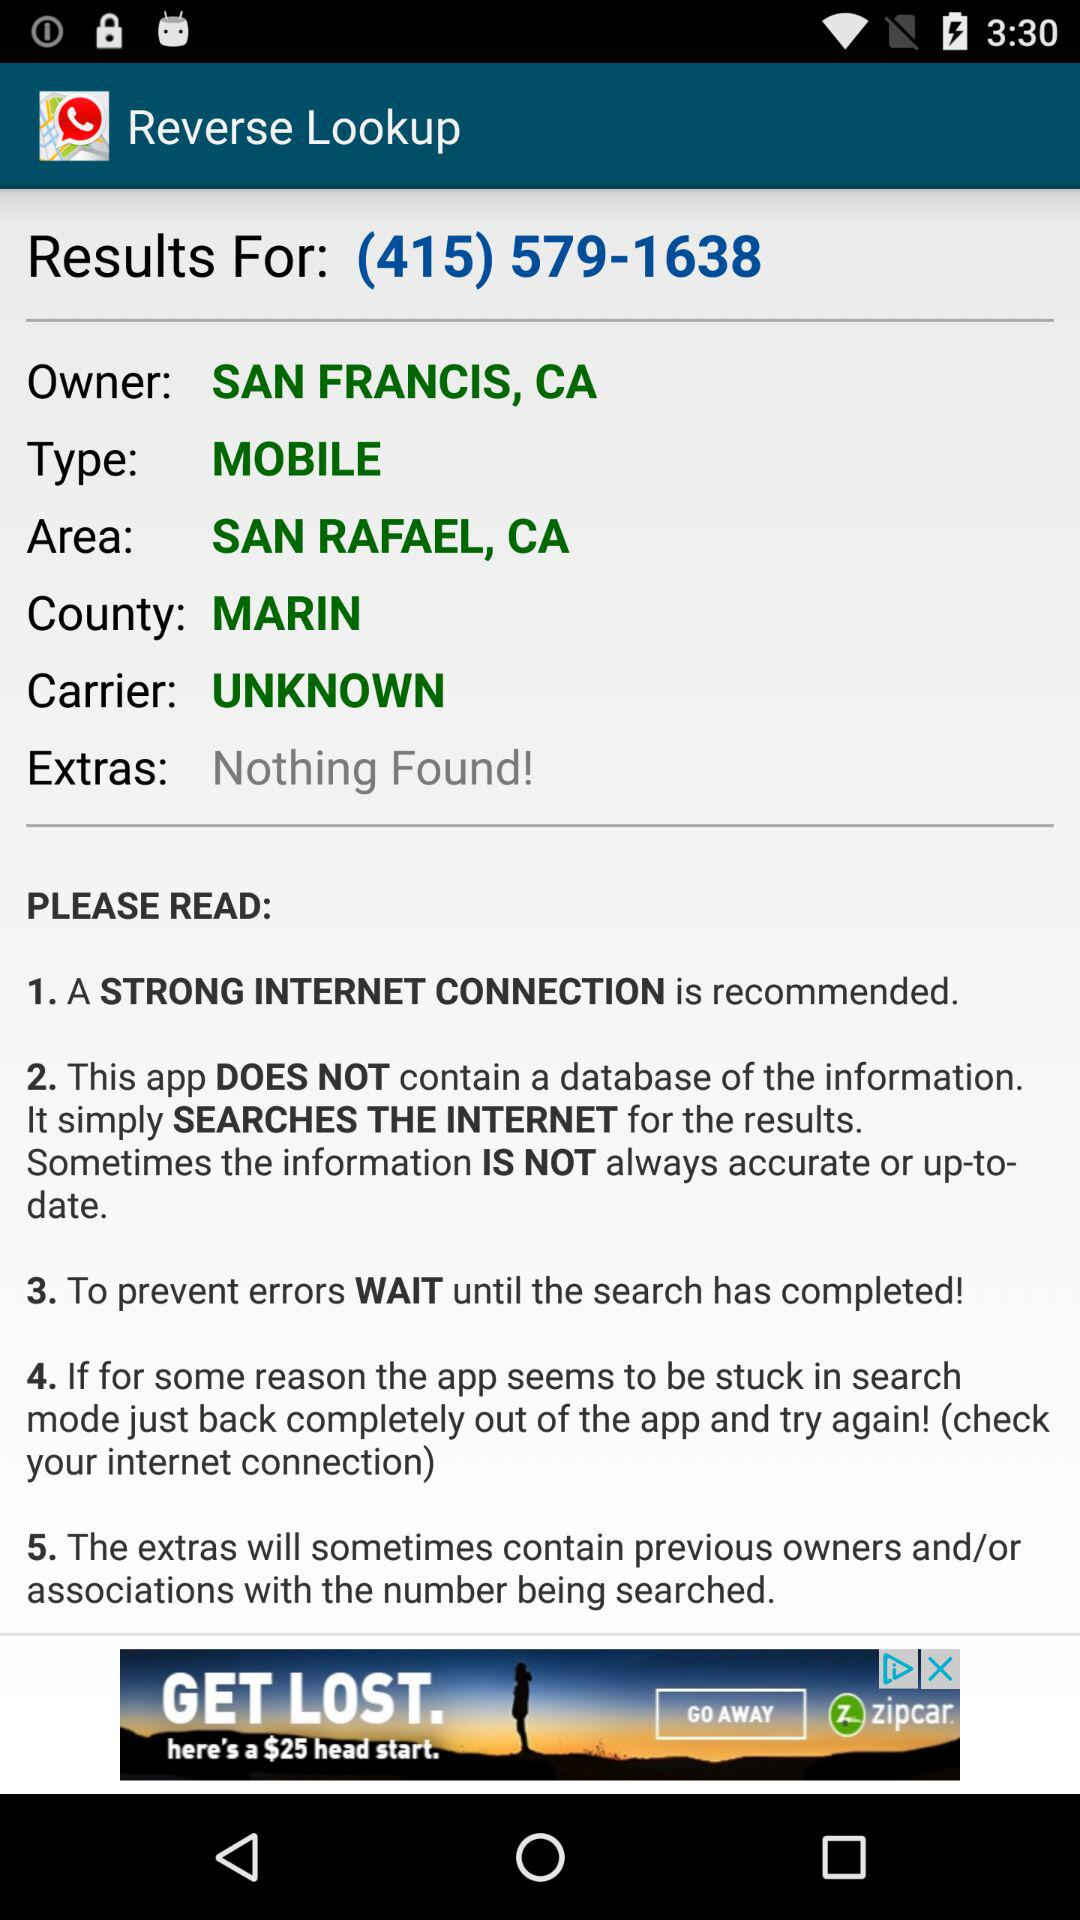Who is the owner? The owner is "SAN FRANCIS, CA". 